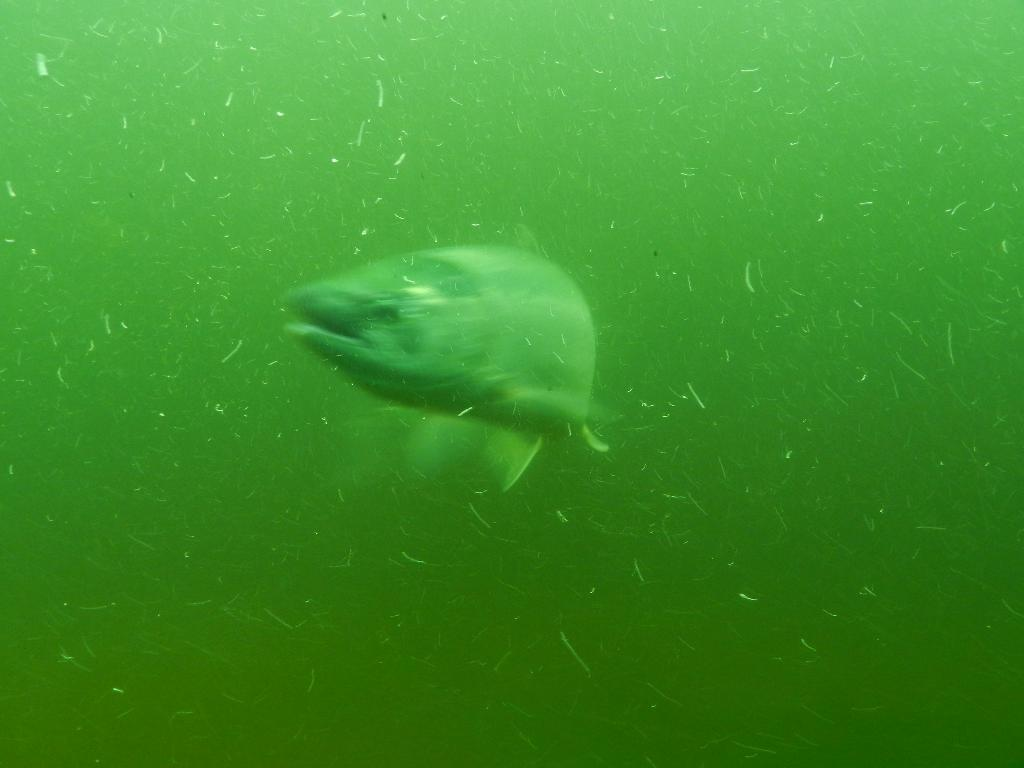What type of animal is present in the image? There is a fish in the image. What is the color of the water in the image? The water in the image is green in color. What statement does the fish make in the image? There is no statement made by the fish in the image, as it is a non-verbal creature. 